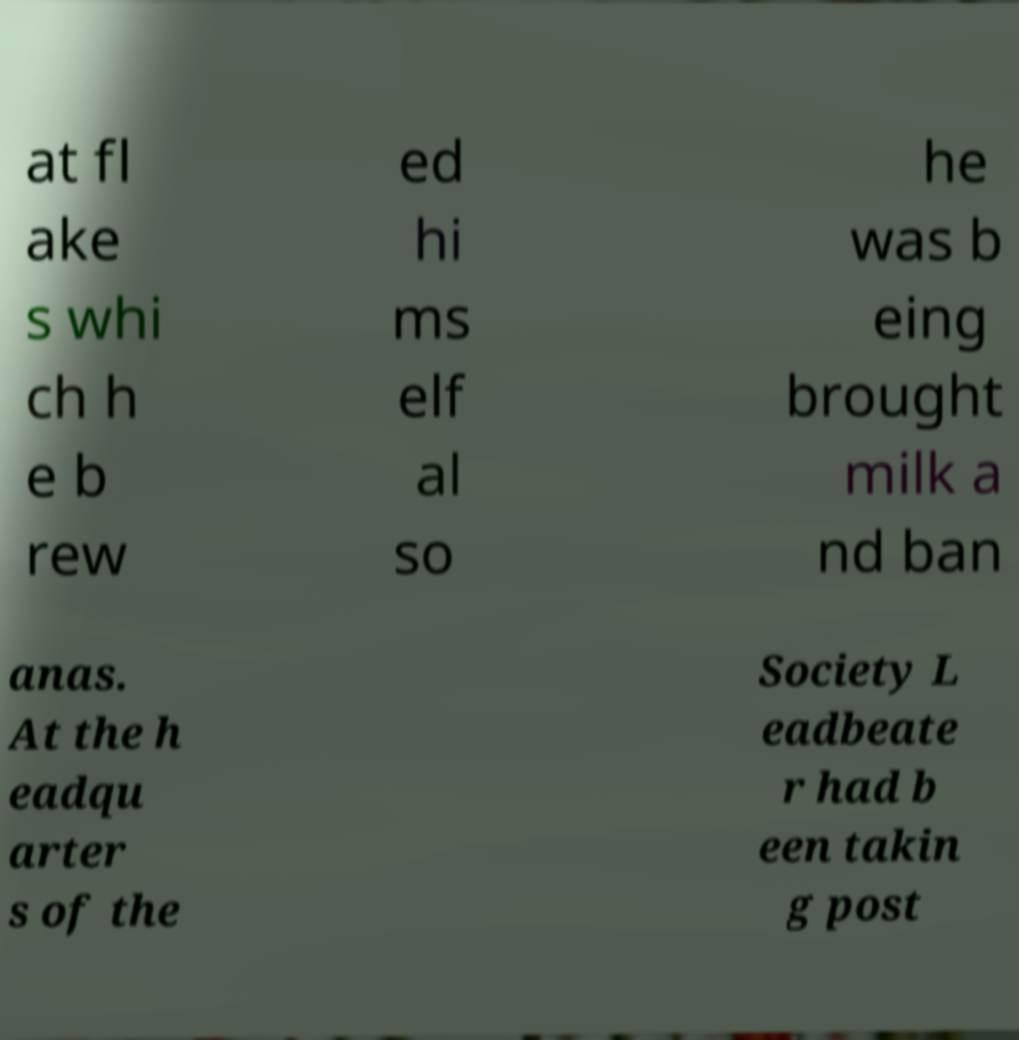What messages or text are displayed in this image? I need them in a readable, typed format. at fl ake s whi ch h e b rew ed hi ms elf al so he was b eing brought milk a nd ban anas. At the h eadqu arter s of the Society L eadbeate r had b een takin g post 